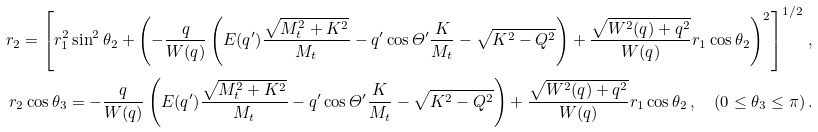<formula> <loc_0><loc_0><loc_500><loc_500>r _ { 2 } = \left [ r _ { 1 } ^ { 2 } \sin ^ { 2 } \theta _ { 2 } + \left ( - \frac { q } { W ( q ) } \left ( E ( q ^ { \prime } ) \frac { \sqrt { M _ { t } ^ { 2 } + K ^ { 2 } } } { M _ { t } } - q ^ { \prime } \cos \varTheta ^ { \prime } \frac { K } { M _ { t } } - \sqrt { K ^ { 2 } - Q ^ { 2 } } \right ) + \frac { \sqrt { W ^ { 2 } ( q ) + q ^ { 2 } } } { W ( q ) } r _ { 1 } \cos \theta _ { 2 } \right ) ^ { 2 } \right ] ^ { 1 / 2 } \, , \\ r _ { 2 } \cos \theta _ { 3 } = - \frac { q } { W ( q ) } \left ( E ( q ^ { \prime } ) \frac { \sqrt { M _ { t } ^ { 2 } + K ^ { 2 } } } { M _ { t } } - q ^ { \prime } \cos \varTheta ^ { \prime } \frac { K } { M _ { t } } - \sqrt { K ^ { 2 } - Q ^ { 2 } } \right ) + \frac { \sqrt { W ^ { 2 } ( q ) + q ^ { 2 } } } { W ( q ) } r _ { 1 } \cos \theta _ { 2 } \, , \quad ( 0 \leq \theta _ { 3 } \leq \pi ) \, .</formula> 